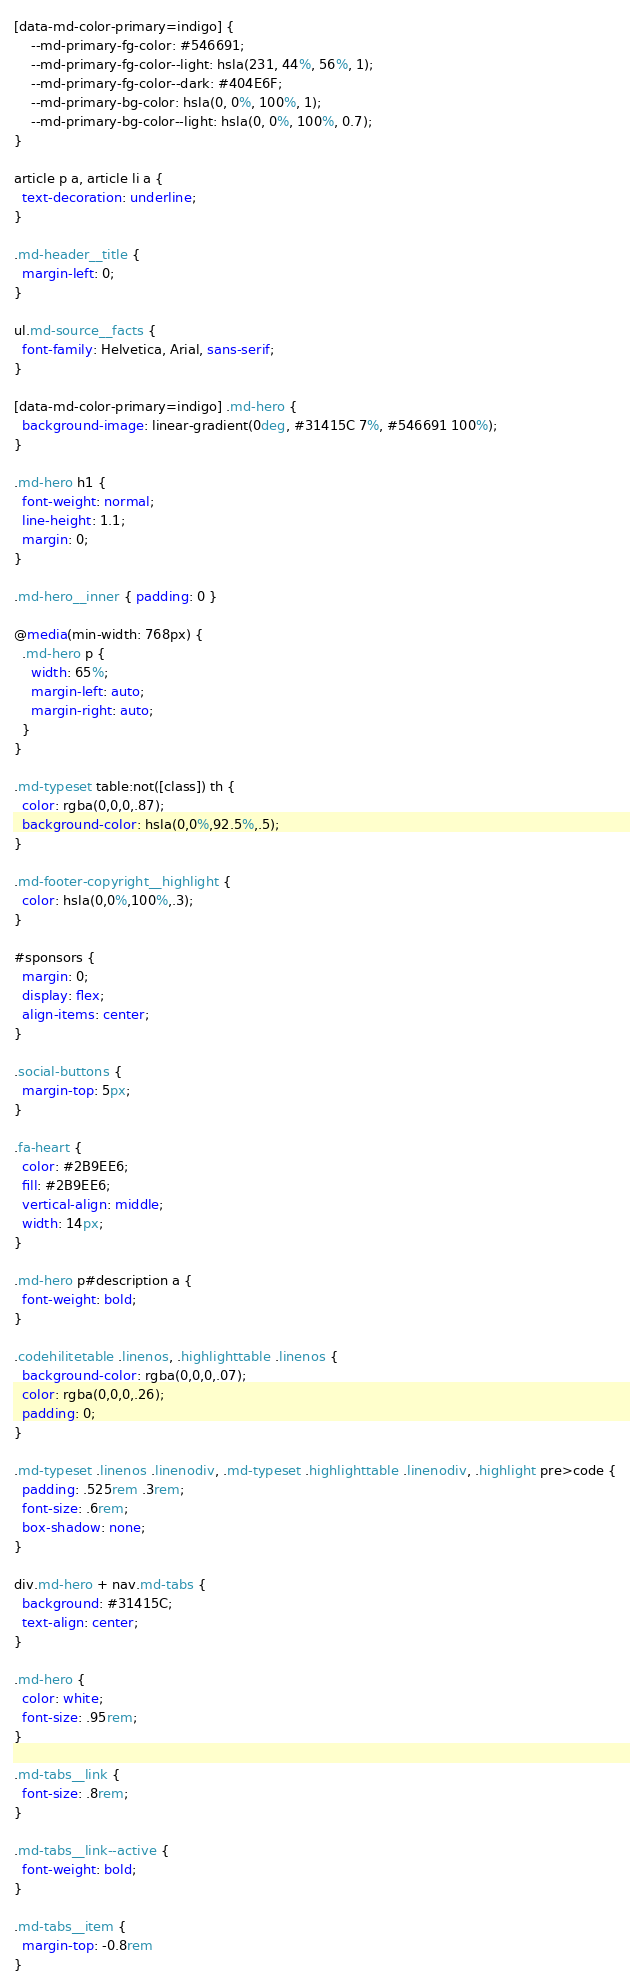Convert code to text. <code><loc_0><loc_0><loc_500><loc_500><_CSS_>
[data-md-color-primary=indigo] {
    --md-primary-fg-color: #546691;
    --md-primary-fg-color--light: hsla(231, 44%, 56%, 1);
    --md-primary-fg-color--dark: #404E6F;
    --md-primary-bg-color: hsla(0, 0%, 100%, 1);
    --md-primary-bg-color--light: hsla(0, 0%, 100%, 0.7);
}

article p a, article li a {
  text-decoration: underline;
}

.md-header__title {
  margin-left: 0;
}

ul.md-source__facts {
  font-family: Helvetica, Arial, sans-serif;
}

[data-md-color-primary=indigo] .md-hero {
  background-image: linear-gradient(0deg, #31415C 7%, #546691 100%);
}

.md-hero h1 {
  font-weight: normal;
  line-height: 1.1;
  margin: 0;
}

.md-hero__inner { padding: 0 }

@media(min-width: 768px) {
  .md-hero p {
    width: 65%;
    margin-left: auto;
    margin-right: auto;
  }
}

.md-typeset table:not([class]) th {
  color: rgba(0,0,0,.87);
  background-color: hsla(0,0%,92.5%,.5);
}

.md-footer-copyright__highlight {
  color: hsla(0,0%,100%,.3);
}

#sponsors {
  margin: 0;
  display: flex;
  align-items: center;
}

.social-buttons {
  margin-top: 5px;
}

.fa-heart {
  color: #2B9EE6;
  fill: #2B9EE6;
  vertical-align: middle;
  width: 14px;
}

.md-hero p#description a {
  font-weight: bold;
}

.codehilitetable .linenos, .highlighttable .linenos {
  background-color: rgba(0,0,0,.07);
  color: rgba(0,0,0,.26);
  padding: 0;
}

.md-typeset .linenos .linenodiv, .md-typeset .highlighttable .linenodiv, .highlight pre>code {
  padding: .525rem .3rem;
  font-size: .6rem;
  box-shadow: none;
}

div.md-hero + nav.md-tabs {
  background: #31415C;
  text-align: center;
}

.md-hero {
  color: white;
  font-size: .95rem;
}

.md-tabs__link {
  font-size: .8rem;
}

.md-tabs__link--active {
  font-weight: bold;
}

.md-tabs__item {
  margin-top: -0.8rem
}
</code> 